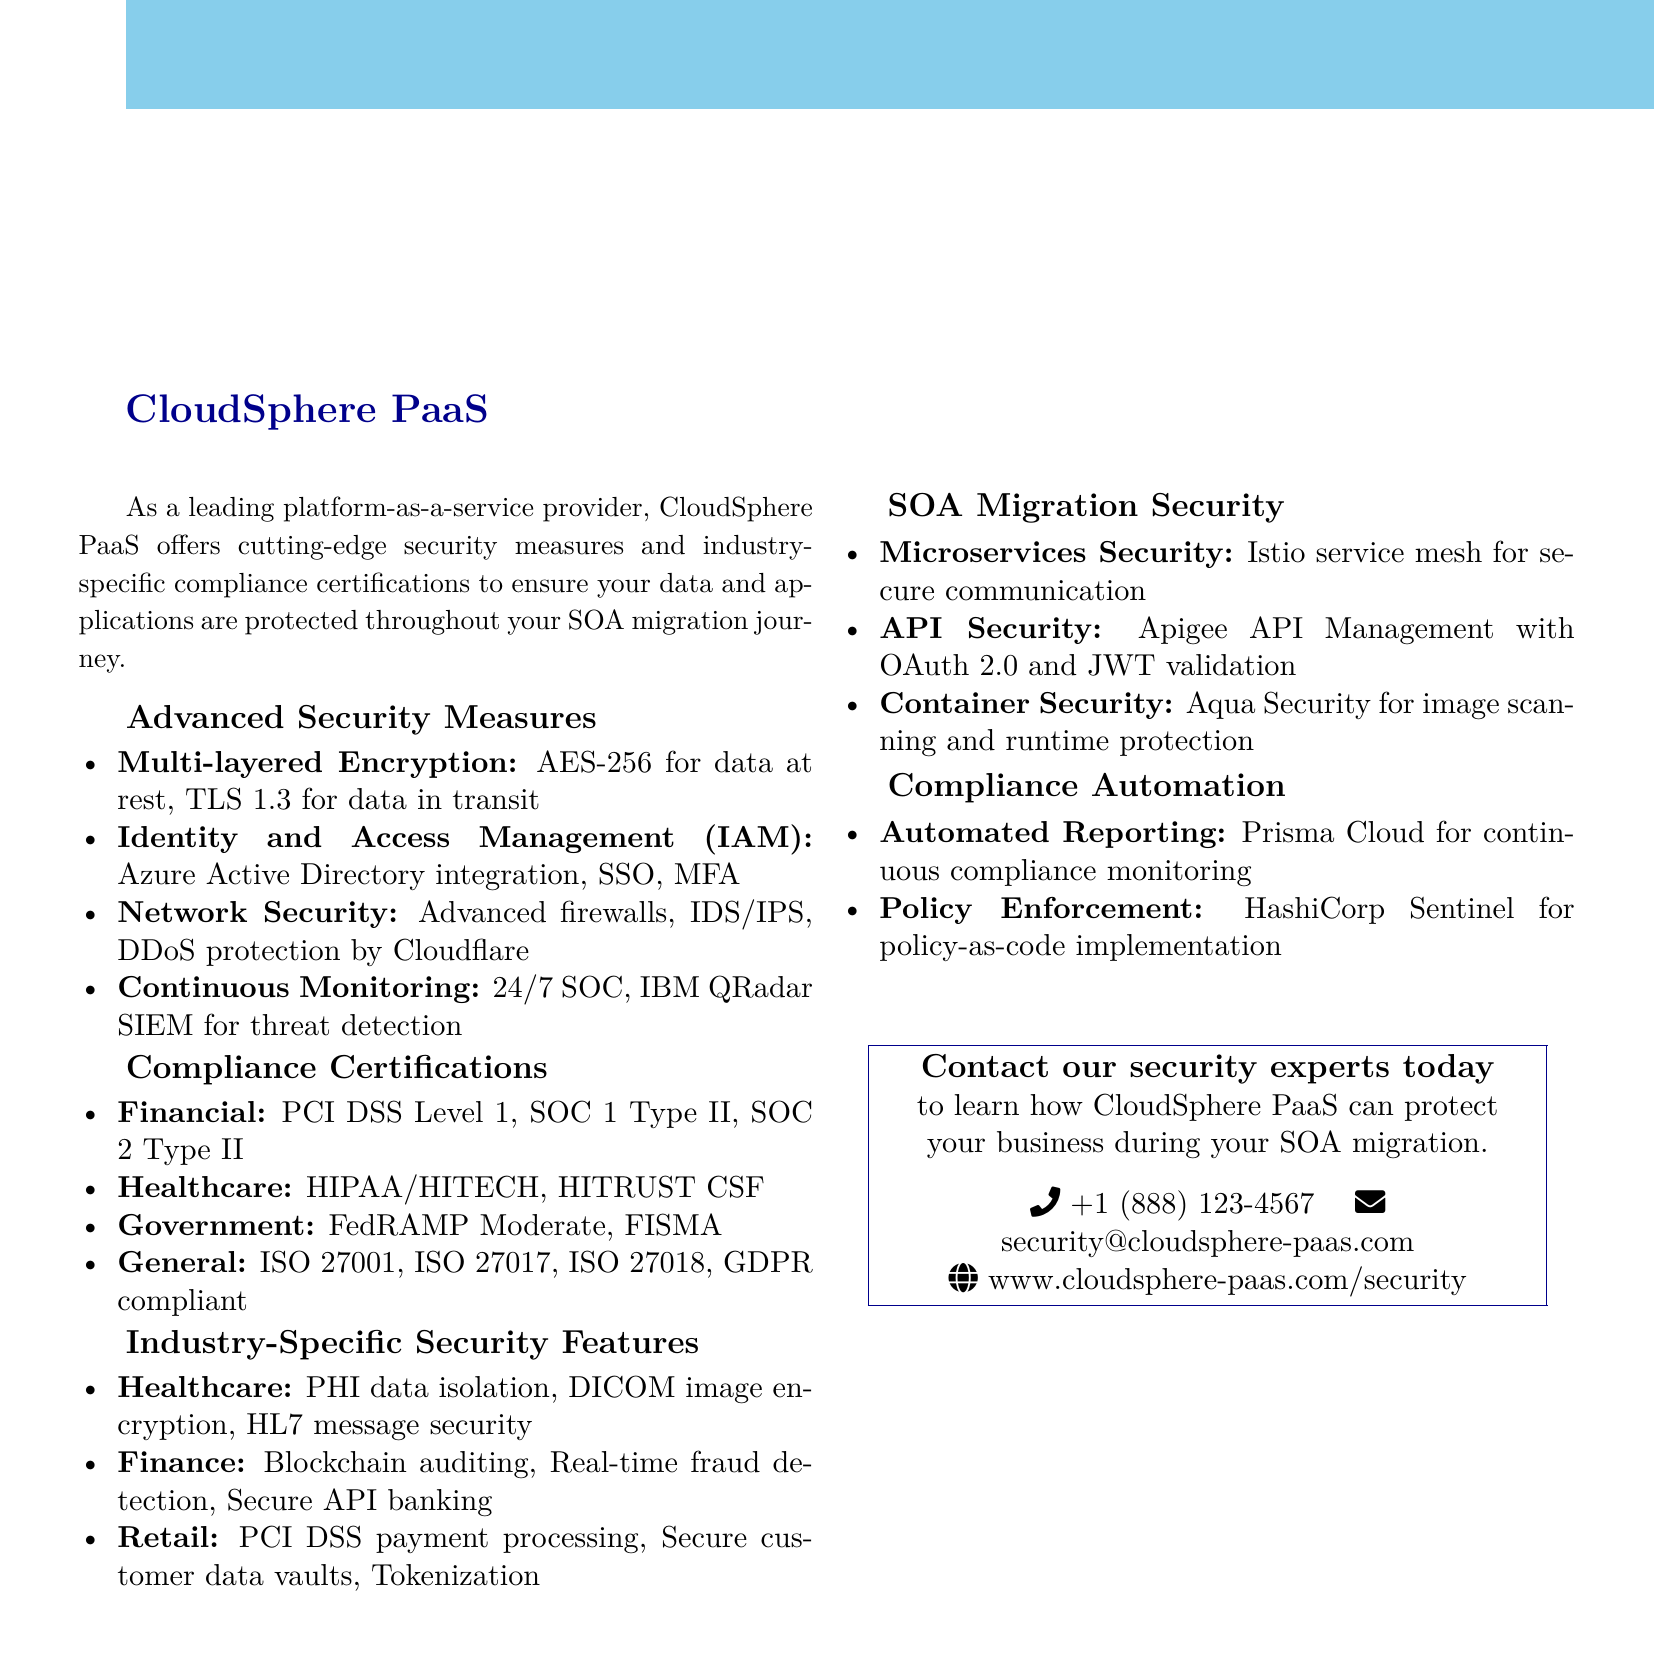what is the title of the brochure? The title of the brochure is prominently displayed at the top of the document, stating the focus on secure cloud solutions.
Answer: Secure Cloud Solutions: Advanced Protection for Your Business how many compliance certifications are listed for Healthcare? The document enumerates specific compliance certifications for the healthcare sector, detailing them clearly.
Answer: 2 which encryption standard is used for data at rest? The brochure specifies the encryption standard utilized for securing data stored within the platform.
Answer: AES-256 what security feature is included for Finance? The document provides examples of industry-specific security features relevant to the finance sector, highlighting critical capabilities.
Answer: Blockchain integration for auditing how can businesses contact CloudSphere PaaS? The document contains contact information for reaching out to CloudSphere PaaS regarding security inquiries.
Answer: security@cloudsphere-paas.com what is the purpose of Prisma Cloud? The document highlights a specific tool within its compliance automation section, indicating its intended function.
Answer: Continuous compliance monitoring which industry has features like PHI data isolation? The document details security features associated with various industries, specifying the one related to personal health information.
Answer: Healthcare how many layers of encryption are mentioned under Advanced Security Measures? The brochure outlines specific security measures, including the encryption protocols and their purposes.
Answer: 2 what type of architecture is recommended for Microservices Security? The document addresses security in the context of microservices, revealing architectural recommendations for securing communications.
Answer: Istio service mesh 